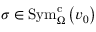<formula> <loc_0><loc_0><loc_500><loc_500>\sigma \in S y m _ { \Omega } ^ { c } \left ( v _ { 0 } \right )</formula> 